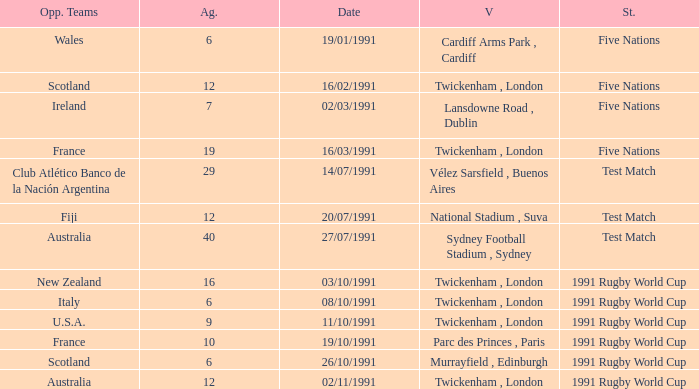Would you mind parsing the complete table? {'header': ['Opp. Teams', 'Ag.', 'Date', 'V', 'St.'], 'rows': [['Wales', '6', '19/01/1991', 'Cardiff Arms Park , Cardiff', 'Five Nations'], ['Scotland', '12', '16/02/1991', 'Twickenham , London', 'Five Nations'], ['Ireland', '7', '02/03/1991', 'Lansdowne Road , Dublin', 'Five Nations'], ['France', '19', '16/03/1991', 'Twickenham , London', 'Five Nations'], ['Club Atlético Banco de la Nación Argentina', '29', '14/07/1991', 'Vélez Sarsfield , Buenos Aires', 'Test Match'], ['Fiji', '12', '20/07/1991', 'National Stadium , Suva', 'Test Match'], ['Australia', '40', '27/07/1991', 'Sydney Football Stadium , Sydney', 'Test Match'], ['New Zealand', '16', '03/10/1991', 'Twickenham , London', '1991 Rugby World Cup'], ['Italy', '6', '08/10/1991', 'Twickenham , London', '1991 Rugby World Cup'], ['U.S.A.', '9', '11/10/1991', 'Twickenham , London', '1991 Rugby World Cup'], ['France', '10', '19/10/1991', 'Parc des Princes , Paris', '1991 Rugby World Cup'], ['Scotland', '6', '26/10/1991', 'Murrayfield , Edinburgh', '1991 Rugby World Cup'], ['Australia', '12', '02/11/1991', 'Twickenham , London', '1991 Rugby World Cup']]} What is Date, when Opposing Teams is "Australia", and when Venue is "Twickenham , London"? 02/11/1991. 